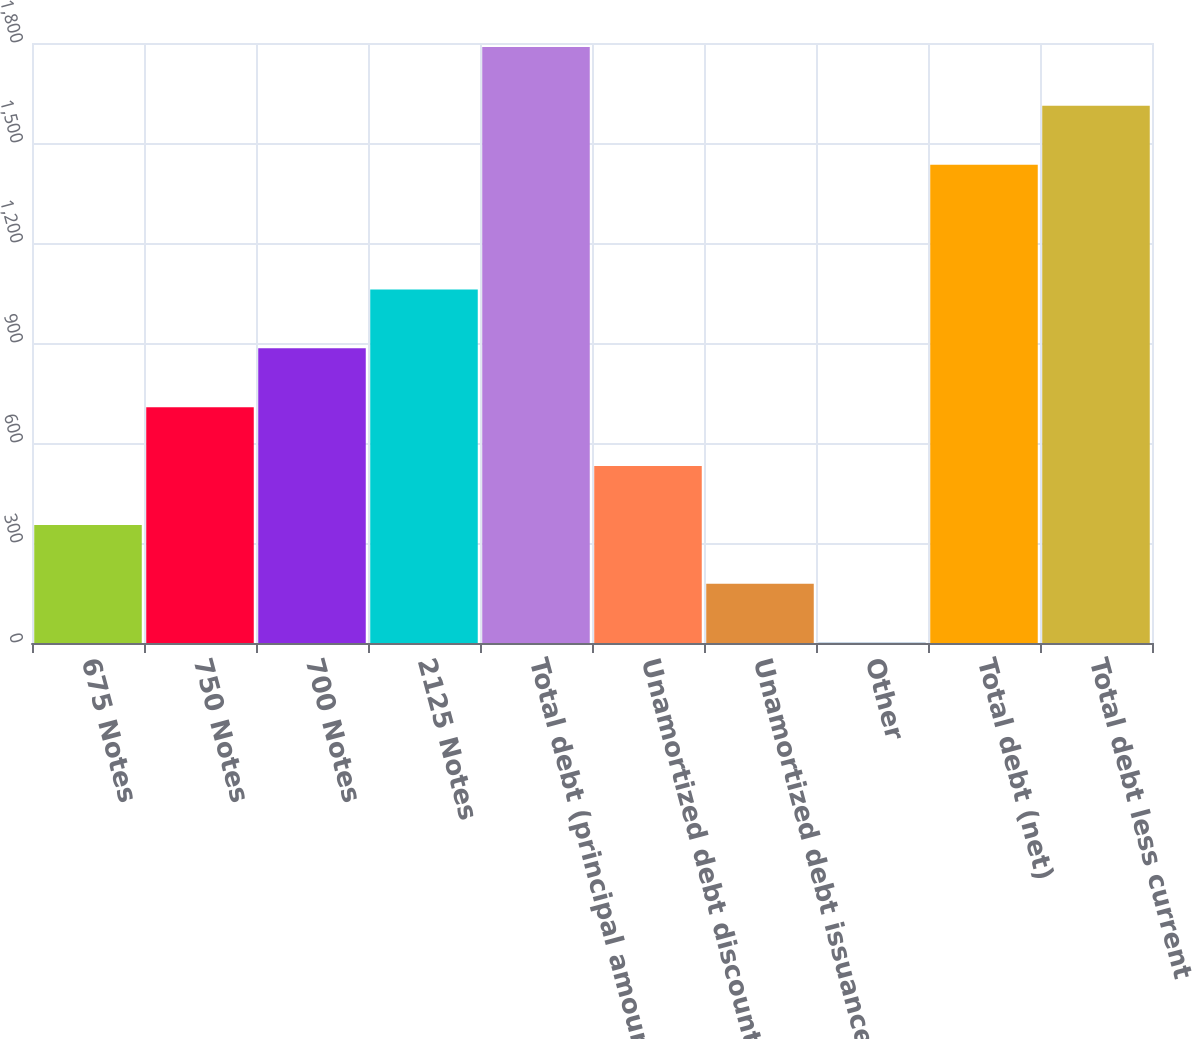Convert chart. <chart><loc_0><loc_0><loc_500><loc_500><bar_chart><fcel>675 Notes<fcel>750 Notes<fcel>700 Notes<fcel>2125 Notes<fcel>Total debt (principal amount)<fcel>Unamortized debt discount<fcel>Unamortized debt issuance<fcel>Other<fcel>Total debt (net)<fcel>Total debt less current<nl><fcel>354.2<fcel>707.4<fcel>884<fcel>1060.6<fcel>1788.2<fcel>530.8<fcel>177.6<fcel>1<fcel>1435<fcel>1611.6<nl></chart> 